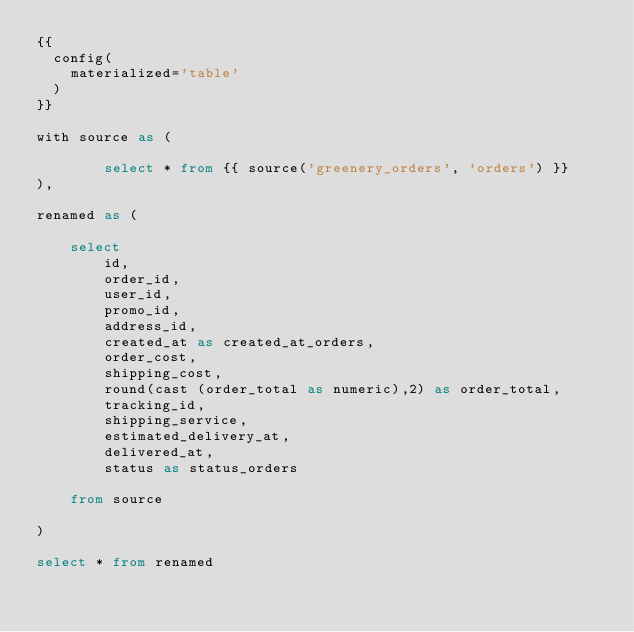Convert code to text. <code><loc_0><loc_0><loc_500><loc_500><_SQL_>{{
  config(
    materialized='table'
  )
}}

with source as (

        select * from {{ source('greenery_orders', 'orders') }}
),

renamed as (

    select
        id,
        order_id,
        user_id,
        promo_id,
        address_id,
        created_at as created_at_orders,
        order_cost,
        shipping_cost,
        round(cast (order_total as numeric),2) as order_total,
        tracking_id,
        shipping_service,
        estimated_delivery_at,
        delivered_at,
        status as status_orders

    from source

)

select * from renamed</code> 